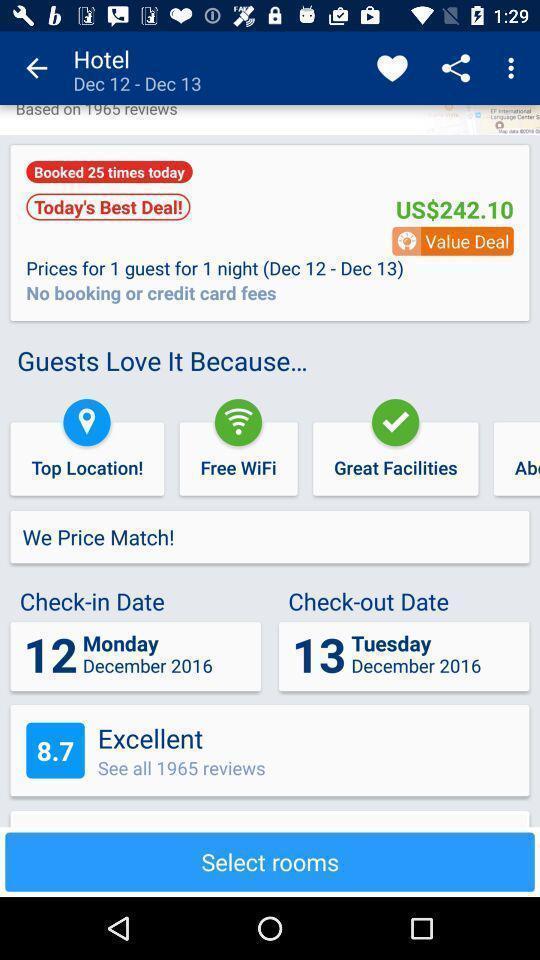Summarize the information in this screenshot. Screen asking to select rooms for hotel. 